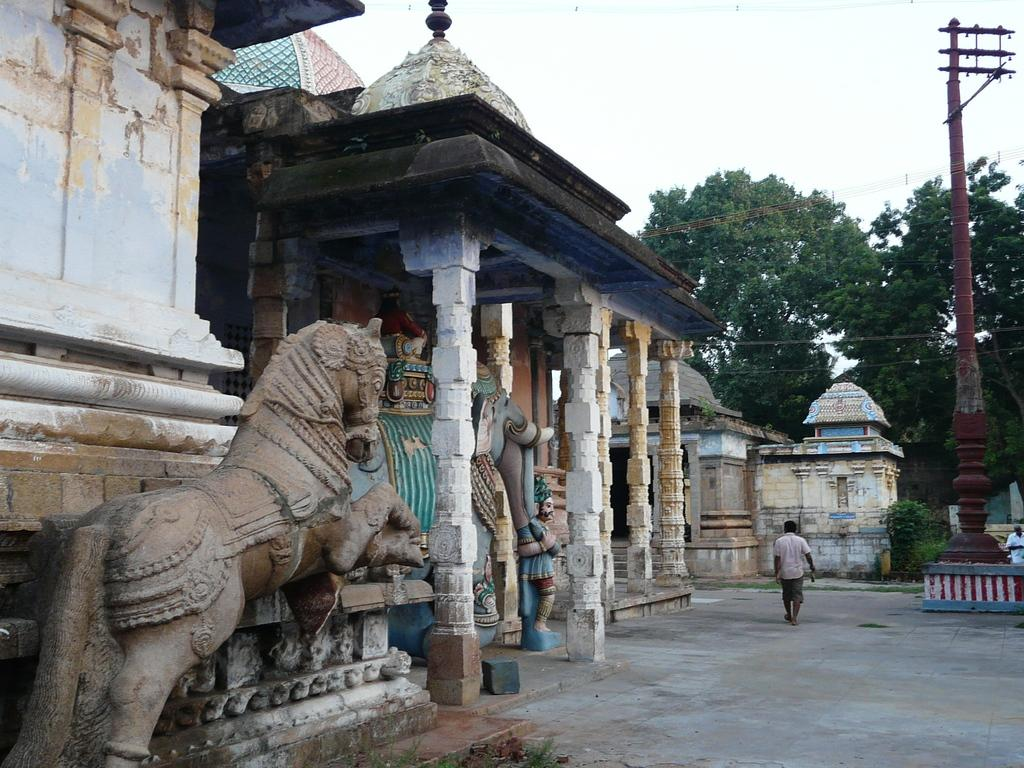What type of structure is in the image? There is a temple in the image. What can be seen inside or around the temple? There are sculptures in the image. How many people are in the image? There are two persons in the image. What is the ground like in the image? The ground is visible in the image. What is the pole used for in the image? The pole's purpose is not clear from the image, but it might be used for hanging something or as a support. What other natural elements are present in the image? There are trees, plants, grass, and the sky visible in the image. What type of disease is being treated by the manager in the image? There is no manager or disease present in the image. What is the manager using the plate for in the image? There is no manager or plate present in the image. 